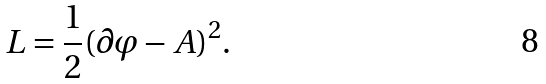<formula> <loc_0><loc_0><loc_500><loc_500>L = \frac { 1 } { 2 } ( \partial \varphi - A ) ^ { 2 } .</formula> 